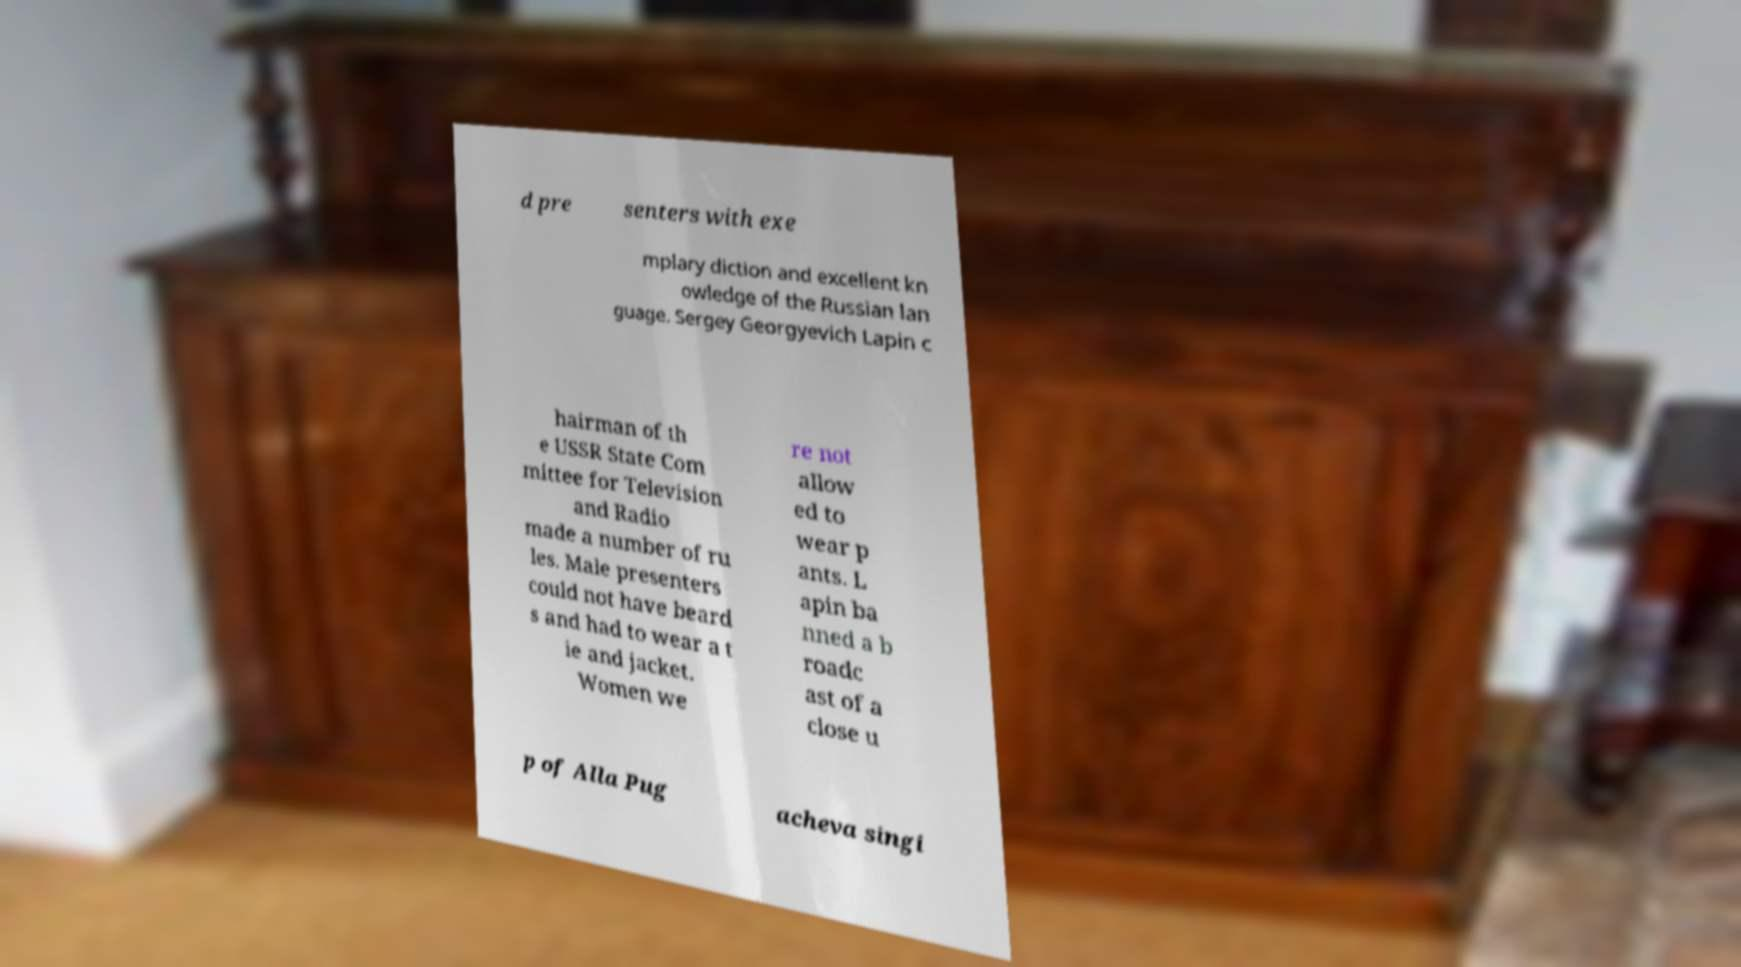Could you assist in decoding the text presented in this image and type it out clearly? d pre senters with exe mplary diction and excellent kn owledge of the Russian lan guage. Sergey Georgyevich Lapin c hairman of th e USSR State Com mittee for Television and Radio made a number of ru les. Male presenters could not have beard s and had to wear a t ie and jacket. Women we re not allow ed to wear p ants. L apin ba nned a b roadc ast of a close u p of Alla Pug acheva singi 